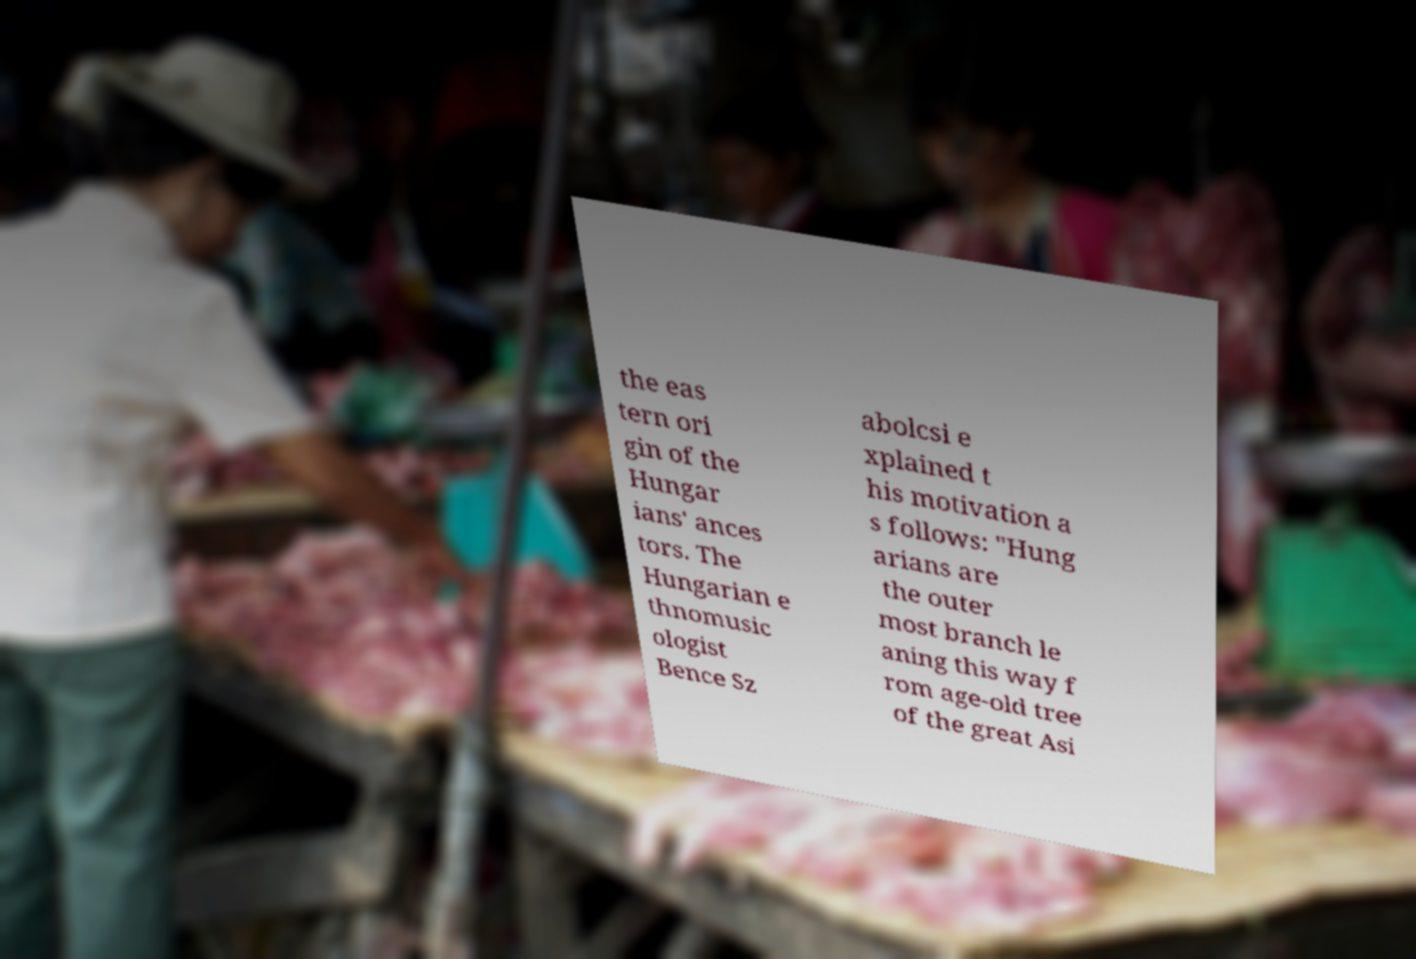For documentation purposes, I need the text within this image transcribed. Could you provide that? the eas tern ori gin of the Hungar ians' ances tors. The Hungarian e thnomusic ologist Bence Sz abolcsi e xplained t his motivation a s follows: "Hung arians are the outer most branch le aning this way f rom age-old tree of the great Asi 